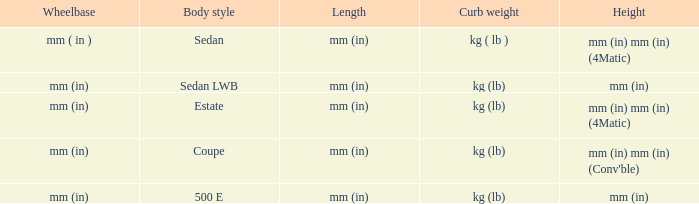What are the lengths of the models that are mm (in) tall? Mm (in), mm (in). 